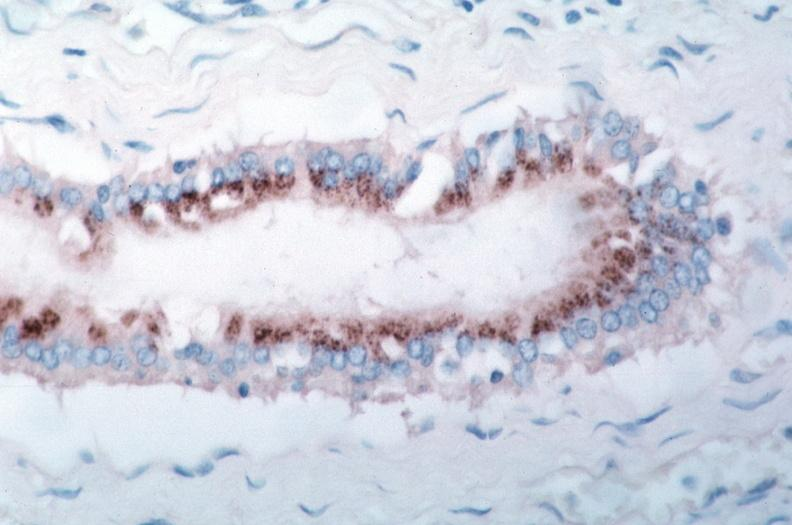s lesion of myocytolysis present?
Answer the question using a single word or phrase. No 